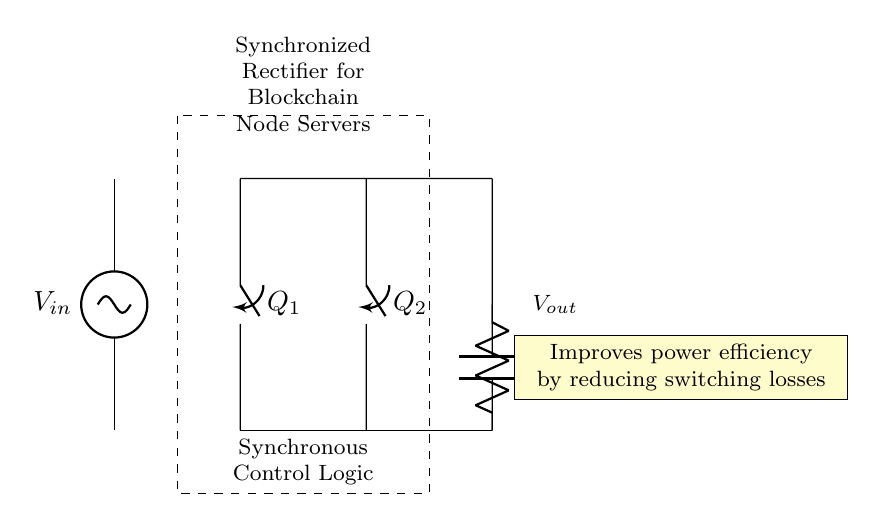What are the main components in this circuit? The circuit includes two synchronous switches labeled Q1 and Q2, a capacitor labeled Cf, a resistor labeled RL, and control logic. These components work together to perform the rectification function.
Answer: Q1, Q2, Cf, RL, Control Logic What does the control logic do in this circuit? The control logic coordinates the operation of the synchronous switches (Q1 and Q2) to minimize switching losses, ensuring efficient rectification by controlling when each switch conducts.
Answer: Control synchronous switches What type of rectifier is shown in this circuit? The circuit is a synchronized rectifier, which uses active components (synchronous switches) rather than diodes to improve efficiency and reduce losses.
Answer: Synchronized rectifier How does this circuit improve power efficiency? The circuit improves power efficiency by using synchronized control to actively switch Q1 and Q2, reducing the energy lost during switching, compared to passive rectifiers.
Answer: Reduces switching losses What is the role of the capacitor in the circuit? The capacitor labeled Cf serves to filter the output, smoothing the rectified voltage and providing a stable DC voltage to the load.
Answer: Filters output voltage What happens if the control logic fails? If the control logic fails, the synchronous switches may not operate correctly, potentially leading to increased losses and inefficient operation of the rectifier, possibly damaging connected components.
Answer: Inefficient operation, potential damage 